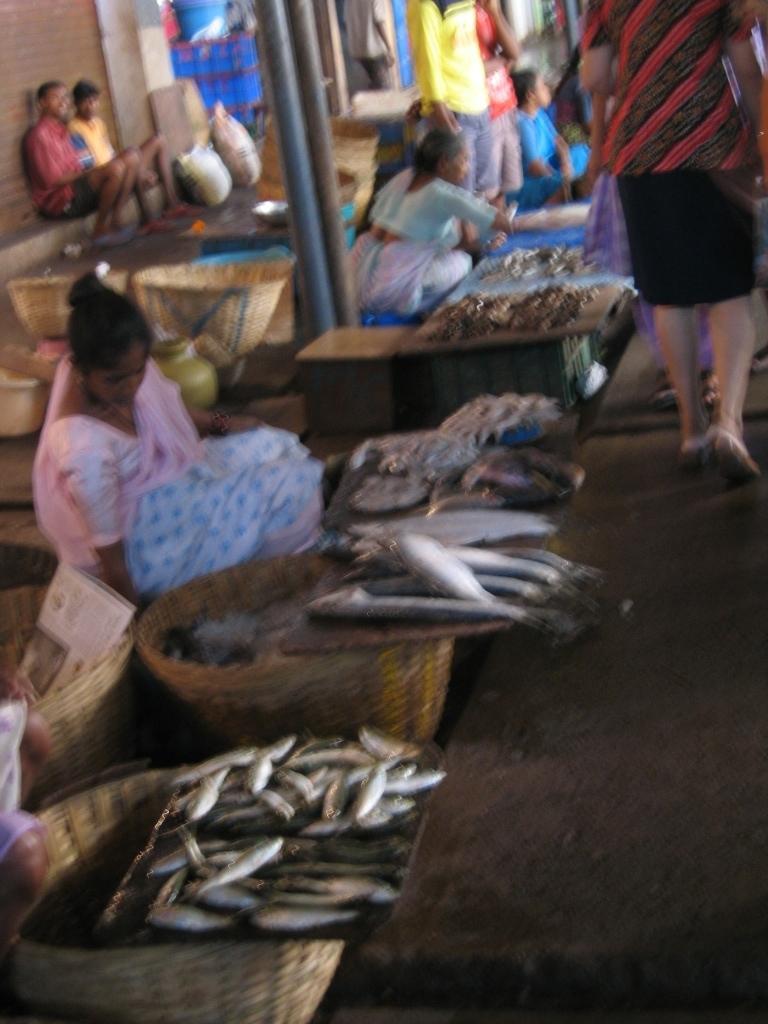Describe this image in one or two sentences. In this picture we can see some people are sitting, on the right side there is a person walking, we can see baskets, some fishes and two bags on the left side, there is a shutter at the left top of the picture, we can see two poles in the middle. 